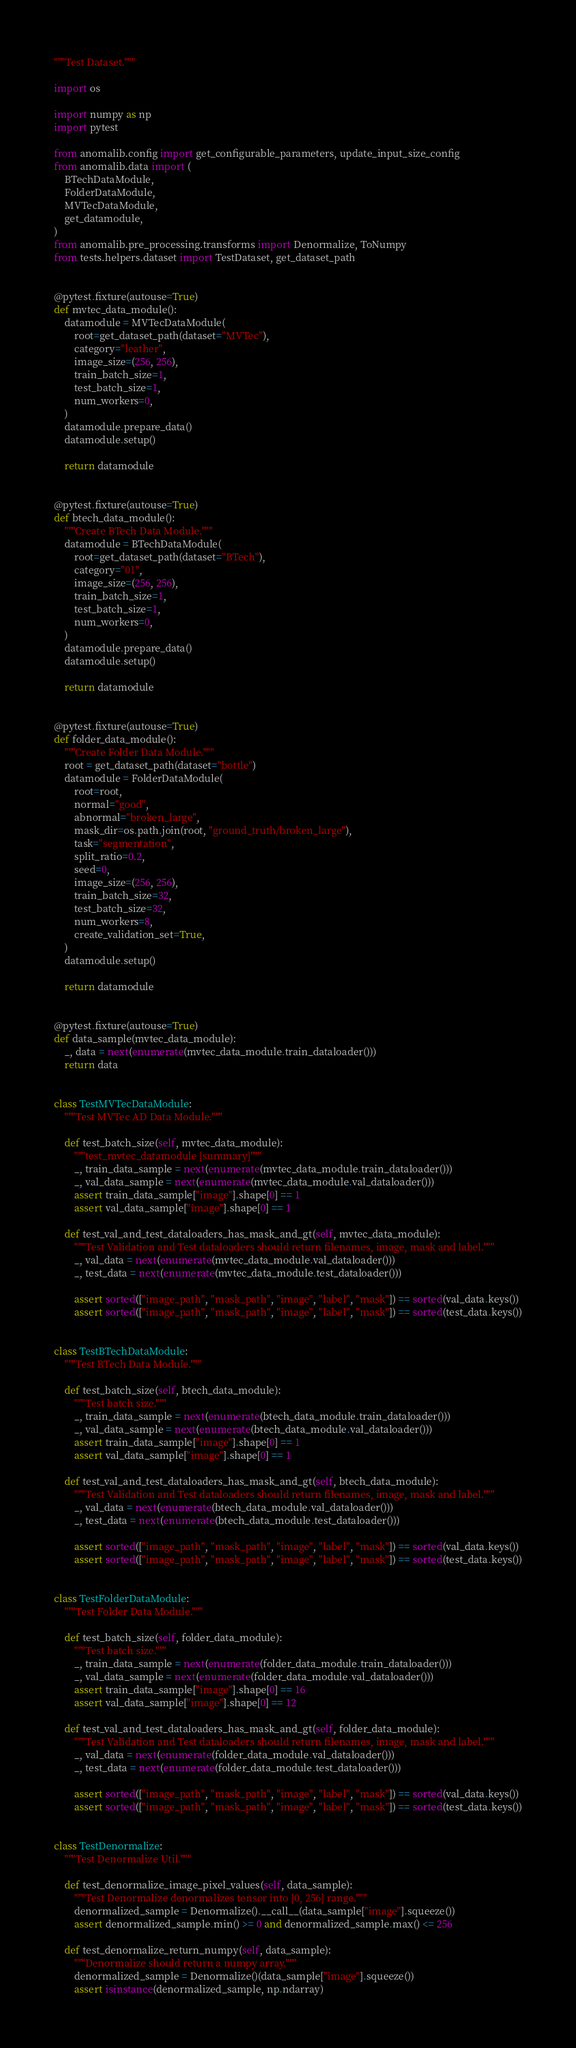Convert code to text. <code><loc_0><loc_0><loc_500><loc_500><_Python_>"""Test Dataset."""

import os

import numpy as np
import pytest

from anomalib.config import get_configurable_parameters, update_input_size_config
from anomalib.data import (
    BTechDataModule,
    FolderDataModule,
    MVTecDataModule,
    get_datamodule,
)
from anomalib.pre_processing.transforms import Denormalize, ToNumpy
from tests.helpers.dataset import TestDataset, get_dataset_path


@pytest.fixture(autouse=True)
def mvtec_data_module():
    datamodule = MVTecDataModule(
        root=get_dataset_path(dataset="MVTec"),
        category="leather",
        image_size=(256, 256),
        train_batch_size=1,
        test_batch_size=1,
        num_workers=0,
    )
    datamodule.prepare_data()
    datamodule.setup()

    return datamodule


@pytest.fixture(autouse=True)
def btech_data_module():
    """Create BTech Data Module."""
    datamodule = BTechDataModule(
        root=get_dataset_path(dataset="BTech"),
        category="01",
        image_size=(256, 256),
        train_batch_size=1,
        test_batch_size=1,
        num_workers=0,
    )
    datamodule.prepare_data()
    datamodule.setup()

    return datamodule


@pytest.fixture(autouse=True)
def folder_data_module():
    """Create Folder Data Module."""
    root = get_dataset_path(dataset="bottle")
    datamodule = FolderDataModule(
        root=root,
        normal="good",
        abnormal="broken_large",
        mask_dir=os.path.join(root, "ground_truth/broken_large"),
        task="segmentation",
        split_ratio=0.2,
        seed=0,
        image_size=(256, 256),
        train_batch_size=32,
        test_batch_size=32,
        num_workers=8,
        create_validation_set=True,
    )
    datamodule.setup()

    return datamodule


@pytest.fixture(autouse=True)
def data_sample(mvtec_data_module):
    _, data = next(enumerate(mvtec_data_module.train_dataloader()))
    return data


class TestMVTecDataModule:
    """Test MVTec AD Data Module."""

    def test_batch_size(self, mvtec_data_module):
        """test_mvtec_datamodule [summary]"""
        _, train_data_sample = next(enumerate(mvtec_data_module.train_dataloader()))
        _, val_data_sample = next(enumerate(mvtec_data_module.val_dataloader()))
        assert train_data_sample["image"].shape[0] == 1
        assert val_data_sample["image"].shape[0] == 1

    def test_val_and_test_dataloaders_has_mask_and_gt(self, mvtec_data_module):
        """Test Validation and Test dataloaders should return filenames, image, mask and label."""
        _, val_data = next(enumerate(mvtec_data_module.val_dataloader()))
        _, test_data = next(enumerate(mvtec_data_module.test_dataloader()))

        assert sorted(["image_path", "mask_path", "image", "label", "mask"]) == sorted(val_data.keys())
        assert sorted(["image_path", "mask_path", "image", "label", "mask"]) == sorted(test_data.keys())


class TestBTechDataModule:
    """Test BTech Data Module."""

    def test_batch_size(self, btech_data_module):
        """Test batch size."""
        _, train_data_sample = next(enumerate(btech_data_module.train_dataloader()))
        _, val_data_sample = next(enumerate(btech_data_module.val_dataloader()))
        assert train_data_sample["image"].shape[0] == 1
        assert val_data_sample["image"].shape[0] == 1

    def test_val_and_test_dataloaders_has_mask_and_gt(self, btech_data_module):
        """Test Validation and Test dataloaders should return filenames, image, mask and label."""
        _, val_data = next(enumerate(btech_data_module.val_dataloader()))
        _, test_data = next(enumerate(btech_data_module.test_dataloader()))

        assert sorted(["image_path", "mask_path", "image", "label", "mask"]) == sorted(val_data.keys())
        assert sorted(["image_path", "mask_path", "image", "label", "mask"]) == sorted(test_data.keys())


class TestFolderDataModule:
    """Test Folder Data Module."""

    def test_batch_size(self, folder_data_module):
        """Test batch size."""
        _, train_data_sample = next(enumerate(folder_data_module.train_dataloader()))
        _, val_data_sample = next(enumerate(folder_data_module.val_dataloader()))
        assert train_data_sample["image"].shape[0] == 16
        assert val_data_sample["image"].shape[0] == 12

    def test_val_and_test_dataloaders_has_mask_and_gt(self, folder_data_module):
        """Test Validation and Test dataloaders should return filenames, image, mask and label."""
        _, val_data = next(enumerate(folder_data_module.val_dataloader()))
        _, test_data = next(enumerate(folder_data_module.test_dataloader()))

        assert sorted(["image_path", "mask_path", "image", "label", "mask"]) == sorted(val_data.keys())
        assert sorted(["image_path", "mask_path", "image", "label", "mask"]) == sorted(test_data.keys())


class TestDenormalize:
    """Test Denormalize Util."""

    def test_denormalize_image_pixel_values(self, data_sample):
        """Test Denormalize denormalizes tensor into [0, 256] range."""
        denormalized_sample = Denormalize().__call__(data_sample["image"].squeeze())
        assert denormalized_sample.min() >= 0 and denormalized_sample.max() <= 256

    def test_denormalize_return_numpy(self, data_sample):
        """Denormalize should return a numpy array."""
        denormalized_sample = Denormalize()(data_sample["image"].squeeze())
        assert isinstance(denormalized_sample, np.ndarray)
</code> 